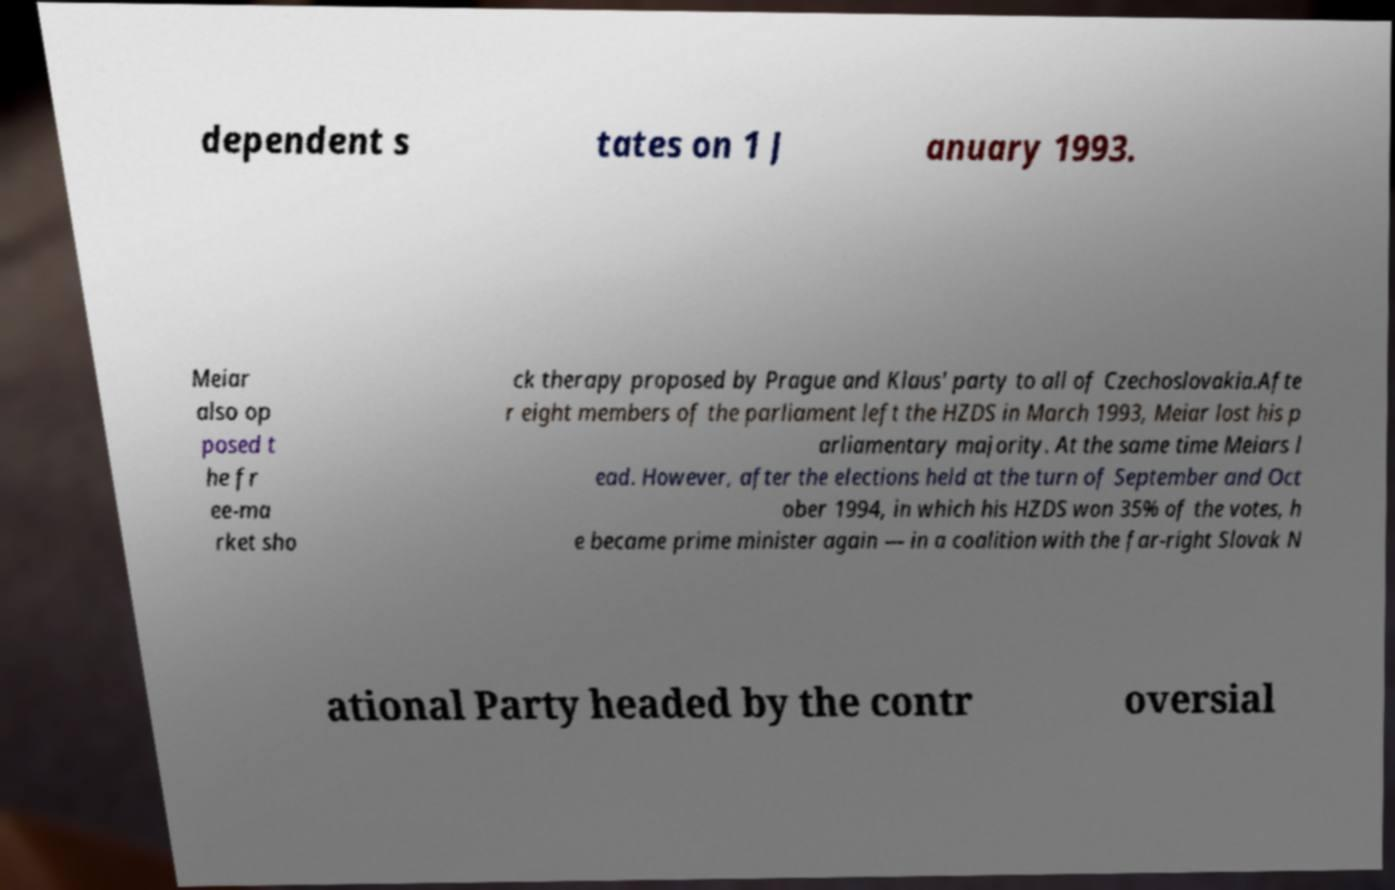For documentation purposes, I need the text within this image transcribed. Could you provide that? dependent s tates on 1 J anuary 1993. Meiar also op posed t he fr ee-ma rket sho ck therapy proposed by Prague and Klaus' party to all of Czechoslovakia.Afte r eight members of the parliament left the HZDS in March 1993, Meiar lost his p arliamentary majority. At the same time Meiars l ead. However, after the elections held at the turn of September and Oct ober 1994, in which his HZDS won 35% of the votes, h e became prime minister again — in a coalition with the far-right Slovak N ational Party headed by the contr oversial 